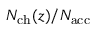Convert formula to latex. <formula><loc_0><loc_0><loc_500><loc_500>N _ { c h } ( z ) / { N _ { a c c } }</formula> 